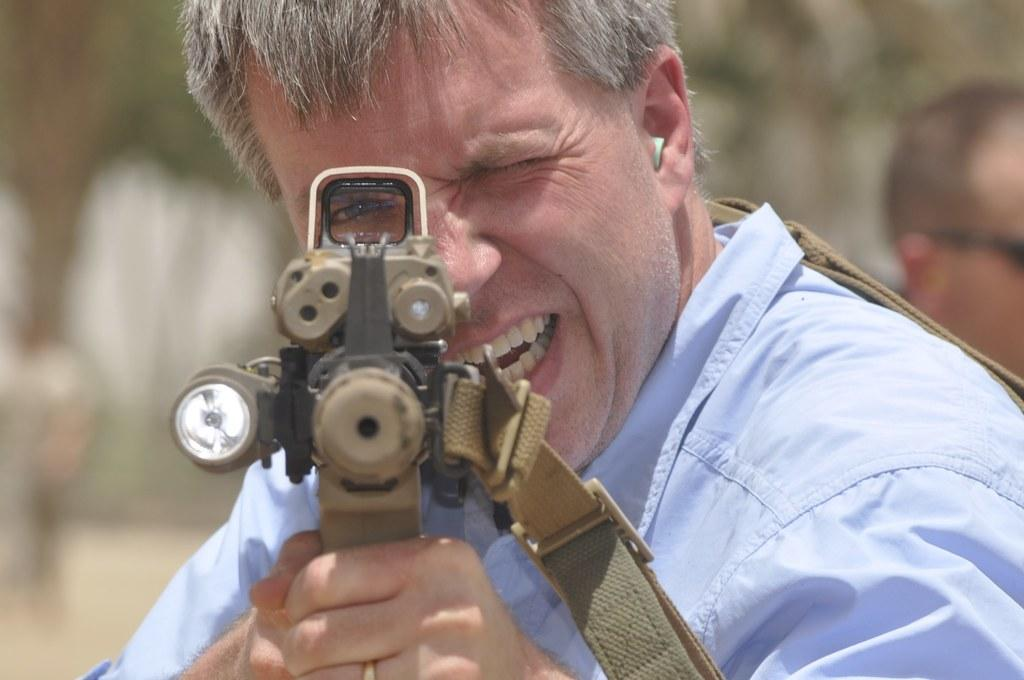Who is present in the image? There is a man in the image. What is the man wearing? The man is wearing a sky blue shirt. What is the man holding in the image? The man is holding a gun. Can you describe the background of the image? The background of the image is blurred. What news is the man's brother sharing in the image? There is no news or brother present in the image; it only features a man holding a gun with a blurred background. 